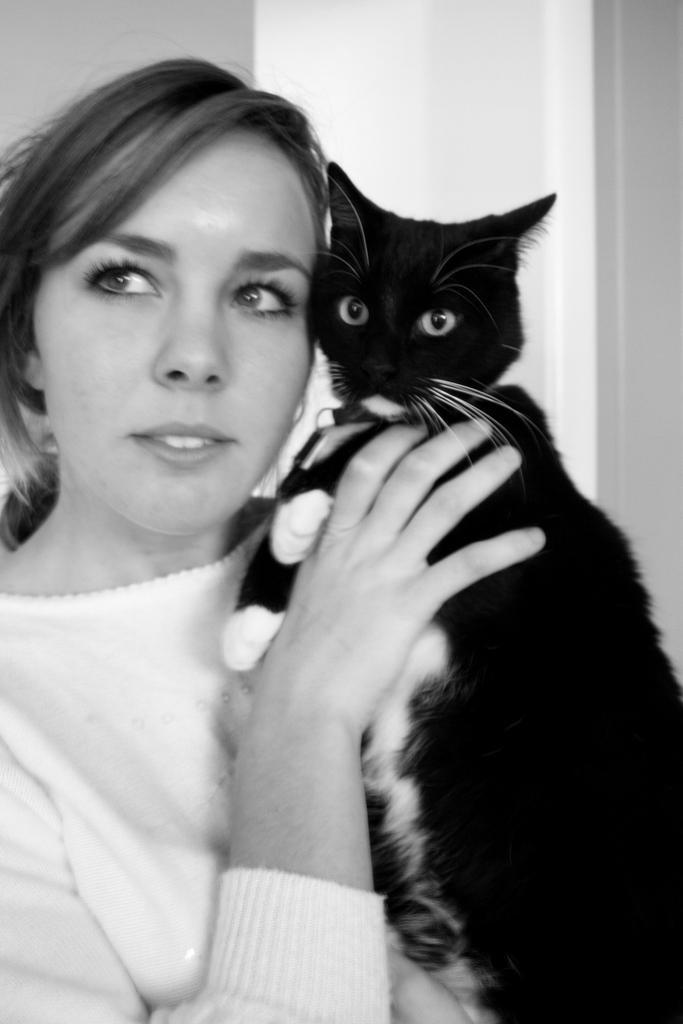How would you summarize this image in a sentence or two? In the image we can see one woman standing and holding cat. In the background there is a wall. 